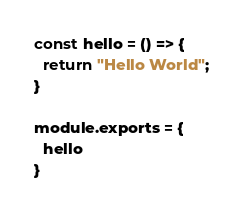Convert code to text. <code><loc_0><loc_0><loc_500><loc_500><_JavaScript_>const hello = () => {
  return "Hello World";
}

module.exports = {
  hello
}
</code> 